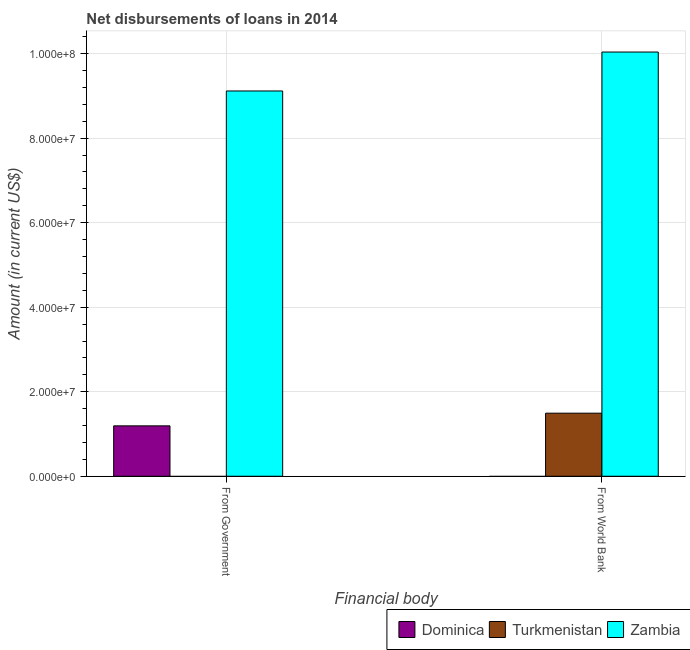How many different coloured bars are there?
Give a very brief answer. 3. Are the number of bars on each tick of the X-axis equal?
Keep it short and to the point. Yes. How many bars are there on the 2nd tick from the left?
Offer a very short reply. 2. How many bars are there on the 2nd tick from the right?
Your answer should be compact. 2. What is the label of the 1st group of bars from the left?
Provide a succinct answer. From Government. What is the net disbursements of loan from government in Turkmenistan?
Keep it short and to the point. 0. Across all countries, what is the maximum net disbursements of loan from world bank?
Provide a short and direct response. 1.00e+08. In which country was the net disbursements of loan from world bank maximum?
Keep it short and to the point. Zambia. What is the total net disbursements of loan from government in the graph?
Offer a terse response. 1.03e+08. What is the difference between the net disbursements of loan from world bank in Turkmenistan and that in Zambia?
Make the answer very short. -8.55e+07. What is the average net disbursements of loan from world bank per country?
Offer a terse response. 3.84e+07. What is the difference between the net disbursements of loan from world bank and net disbursements of loan from government in Zambia?
Your answer should be compact. 9.21e+06. What is the ratio of the net disbursements of loan from world bank in Zambia to that in Turkmenistan?
Your answer should be very brief. 6.73. Are all the bars in the graph horizontal?
Keep it short and to the point. No. Are the values on the major ticks of Y-axis written in scientific E-notation?
Make the answer very short. Yes. Does the graph contain any zero values?
Your answer should be compact. Yes. Where does the legend appear in the graph?
Ensure brevity in your answer.  Bottom right. How are the legend labels stacked?
Offer a terse response. Horizontal. What is the title of the graph?
Your answer should be compact. Net disbursements of loans in 2014. Does "Poland" appear as one of the legend labels in the graph?
Keep it short and to the point. No. What is the label or title of the X-axis?
Offer a very short reply. Financial body. What is the Amount (in current US$) of Dominica in From Government?
Your response must be concise. 1.19e+07. What is the Amount (in current US$) of Zambia in From Government?
Your answer should be very brief. 9.12e+07. What is the Amount (in current US$) in Turkmenistan in From World Bank?
Ensure brevity in your answer.  1.49e+07. What is the Amount (in current US$) in Zambia in From World Bank?
Keep it short and to the point. 1.00e+08. Across all Financial body, what is the maximum Amount (in current US$) in Dominica?
Provide a short and direct response. 1.19e+07. Across all Financial body, what is the maximum Amount (in current US$) of Turkmenistan?
Ensure brevity in your answer.  1.49e+07. Across all Financial body, what is the maximum Amount (in current US$) in Zambia?
Give a very brief answer. 1.00e+08. Across all Financial body, what is the minimum Amount (in current US$) in Zambia?
Provide a succinct answer. 9.12e+07. What is the total Amount (in current US$) of Dominica in the graph?
Make the answer very short. 1.19e+07. What is the total Amount (in current US$) in Turkmenistan in the graph?
Ensure brevity in your answer.  1.49e+07. What is the total Amount (in current US$) in Zambia in the graph?
Provide a short and direct response. 1.92e+08. What is the difference between the Amount (in current US$) of Zambia in From Government and that in From World Bank?
Offer a very short reply. -9.21e+06. What is the difference between the Amount (in current US$) of Dominica in From Government and the Amount (in current US$) of Turkmenistan in From World Bank?
Offer a very short reply. -3.00e+06. What is the difference between the Amount (in current US$) in Dominica in From Government and the Amount (in current US$) in Zambia in From World Bank?
Give a very brief answer. -8.84e+07. What is the average Amount (in current US$) of Dominica per Financial body?
Ensure brevity in your answer.  5.96e+06. What is the average Amount (in current US$) of Turkmenistan per Financial body?
Your answer should be compact. 7.46e+06. What is the average Amount (in current US$) of Zambia per Financial body?
Provide a short and direct response. 9.58e+07. What is the difference between the Amount (in current US$) in Dominica and Amount (in current US$) in Zambia in From Government?
Offer a terse response. -7.92e+07. What is the difference between the Amount (in current US$) in Turkmenistan and Amount (in current US$) in Zambia in From World Bank?
Provide a short and direct response. -8.55e+07. What is the ratio of the Amount (in current US$) of Zambia in From Government to that in From World Bank?
Offer a terse response. 0.91. What is the difference between the highest and the second highest Amount (in current US$) in Zambia?
Offer a terse response. 9.21e+06. What is the difference between the highest and the lowest Amount (in current US$) in Dominica?
Keep it short and to the point. 1.19e+07. What is the difference between the highest and the lowest Amount (in current US$) of Turkmenistan?
Your answer should be very brief. 1.49e+07. What is the difference between the highest and the lowest Amount (in current US$) of Zambia?
Your answer should be compact. 9.21e+06. 